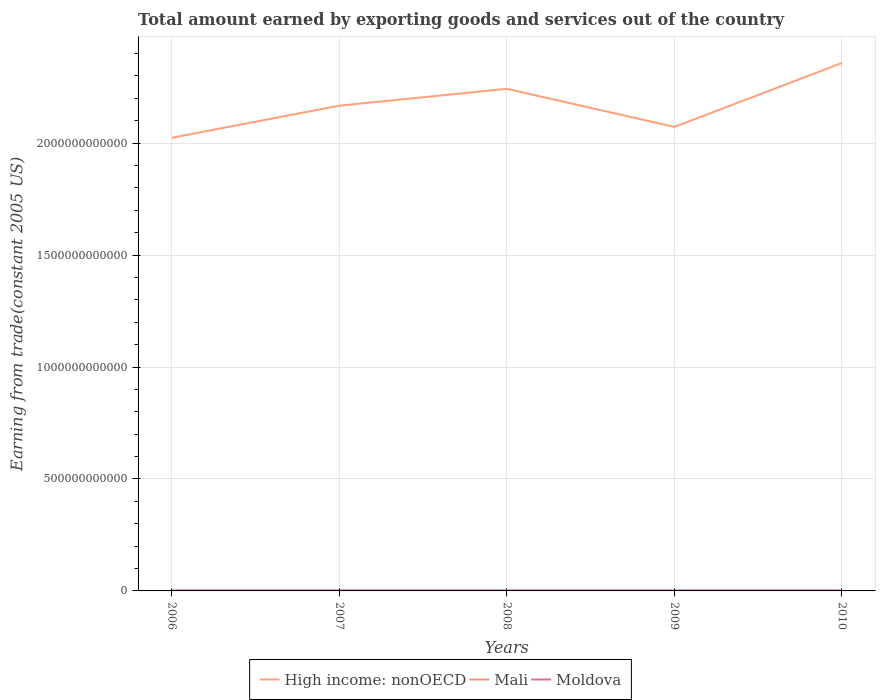How many different coloured lines are there?
Provide a succinct answer. 3. Does the line corresponding to Moldova intersect with the line corresponding to High income: nonOECD?
Ensure brevity in your answer.  No. Is the number of lines equal to the number of legend labels?
Make the answer very short. Yes. Across all years, what is the maximum total amount earned by exporting goods and services in High income: nonOECD?
Offer a very short reply. 2.02e+12. In which year was the total amount earned by exporting goods and services in High income: nonOECD maximum?
Give a very brief answer. 2006. What is the total total amount earned by exporting goods and services in High income: nonOECD in the graph?
Your response must be concise. -1.15e+11. What is the difference between the highest and the second highest total amount earned by exporting goods and services in Mali?
Your response must be concise. 1.81e+08. Is the total amount earned by exporting goods and services in Mali strictly greater than the total amount earned by exporting goods and services in Moldova over the years?
Provide a succinct answer. Yes. What is the difference between two consecutive major ticks on the Y-axis?
Offer a terse response. 5.00e+11. Does the graph contain grids?
Provide a short and direct response. Yes. Where does the legend appear in the graph?
Make the answer very short. Bottom center. How many legend labels are there?
Your response must be concise. 3. What is the title of the graph?
Give a very brief answer. Total amount earned by exporting goods and services out of the country. What is the label or title of the Y-axis?
Provide a succinct answer. Earning from trade(constant 2005 US). What is the Earning from trade(constant 2005 US) of High income: nonOECD in 2006?
Your answer should be compact. 2.02e+12. What is the Earning from trade(constant 2005 US) of Mali in 2006?
Your response must be concise. 1.39e+09. What is the Earning from trade(constant 2005 US) of Moldova in 2006?
Your response must be concise. 1.53e+09. What is the Earning from trade(constant 2005 US) of High income: nonOECD in 2007?
Your response must be concise. 2.17e+12. What is the Earning from trade(constant 2005 US) in Mali in 2007?
Your response must be concise. 1.40e+09. What is the Earning from trade(constant 2005 US) of Moldova in 2007?
Offer a terse response. 1.76e+09. What is the Earning from trade(constant 2005 US) of High income: nonOECD in 2008?
Keep it short and to the point. 2.24e+12. What is the Earning from trade(constant 2005 US) in Mali in 2008?
Keep it short and to the point. 1.22e+09. What is the Earning from trade(constant 2005 US) of Moldova in 2008?
Your answer should be compact. 1.75e+09. What is the Earning from trade(constant 2005 US) in High income: nonOECD in 2009?
Offer a terse response. 2.07e+12. What is the Earning from trade(constant 2005 US) in Mali in 2009?
Ensure brevity in your answer.  1.24e+09. What is the Earning from trade(constant 2005 US) in Moldova in 2009?
Your response must be concise. 1.53e+09. What is the Earning from trade(constant 2005 US) of High income: nonOECD in 2010?
Make the answer very short. 2.36e+12. What is the Earning from trade(constant 2005 US) in Mali in 2010?
Your response must be concise. 1.30e+09. What is the Earning from trade(constant 2005 US) of Moldova in 2010?
Your response must be concise. 1.74e+09. Across all years, what is the maximum Earning from trade(constant 2005 US) of High income: nonOECD?
Your answer should be compact. 2.36e+12. Across all years, what is the maximum Earning from trade(constant 2005 US) in Mali?
Give a very brief answer. 1.40e+09. Across all years, what is the maximum Earning from trade(constant 2005 US) of Moldova?
Give a very brief answer. 1.76e+09. Across all years, what is the minimum Earning from trade(constant 2005 US) in High income: nonOECD?
Offer a very short reply. 2.02e+12. Across all years, what is the minimum Earning from trade(constant 2005 US) of Mali?
Offer a terse response. 1.22e+09. Across all years, what is the minimum Earning from trade(constant 2005 US) of Moldova?
Offer a terse response. 1.53e+09. What is the total Earning from trade(constant 2005 US) in High income: nonOECD in the graph?
Offer a terse response. 1.09e+13. What is the total Earning from trade(constant 2005 US) of Mali in the graph?
Provide a succinct answer. 6.54e+09. What is the total Earning from trade(constant 2005 US) in Moldova in the graph?
Give a very brief answer. 8.31e+09. What is the difference between the Earning from trade(constant 2005 US) of High income: nonOECD in 2006 and that in 2007?
Make the answer very short. -1.43e+11. What is the difference between the Earning from trade(constant 2005 US) in Mali in 2006 and that in 2007?
Make the answer very short. -6.96e+06. What is the difference between the Earning from trade(constant 2005 US) in Moldova in 2006 and that in 2007?
Offer a very short reply. -2.30e+08. What is the difference between the Earning from trade(constant 2005 US) in High income: nonOECD in 2006 and that in 2008?
Your response must be concise. -2.19e+11. What is the difference between the Earning from trade(constant 2005 US) of Mali in 2006 and that in 2008?
Your response must be concise. 1.74e+08. What is the difference between the Earning from trade(constant 2005 US) of Moldova in 2006 and that in 2008?
Keep it short and to the point. -2.18e+08. What is the difference between the Earning from trade(constant 2005 US) in High income: nonOECD in 2006 and that in 2009?
Offer a very short reply. -4.86e+1. What is the difference between the Earning from trade(constant 2005 US) of Mali in 2006 and that in 2009?
Your answer should be compact. 1.56e+08. What is the difference between the Earning from trade(constant 2005 US) in Moldova in 2006 and that in 2009?
Make the answer very short. -7.12e+06. What is the difference between the Earning from trade(constant 2005 US) in High income: nonOECD in 2006 and that in 2010?
Ensure brevity in your answer.  -3.34e+11. What is the difference between the Earning from trade(constant 2005 US) of Mali in 2006 and that in 2010?
Your response must be concise. 8.84e+07. What is the difference between the Earning from trade(constant 2005 US) of Moldova in 2006 and that in 2010?
Provide a succinct answer. -2.18e+08. What is the difference between the Earning from trade(constant 2005 US) of High income: nonOECD in 2007 and that in 2008?
Make the answer very short. -7.52e+1. What is the difference between the Earning from trade(constant 2005 US) of Mali in 2007 and that in 2008?
Offer a very short reply. 1.81e+08. What is the difference between the Earning from trade(constant 2005 US) in Moldova in 2007 and that in 2008?
Your answer should be very brief. 1.15e+07. What is the difference between the Earning from trade(constant 2005 US) in High income: nonOECD in 2007 and that in 2009?
Ensure brevity in your answer.  9.49e+1. What is the difference between the Earning from trade(constant 2005 US) of Mali in 2007 and that in 2009?
Provide a short and direct response. 1.63e+08. What is the difference between the Earning from trade(constant 2005 US) in Moldova in 2007 and that in 2009?
Provide a succinct answer. 2.23e+08. What is the difference between the Earning from trade(constant 2005 US) of High income: nonOECD in 2007 and that in 2010?
Your response must be concise. -1.91e+11. What is the difference between the Earning from trade(constant 2005 US) in Mali in 2007 and that in 2010?
Ensure brevity in your answer.  9.54e+07. What is the difference between the Earning from trade(constant 2005 US) in Moldova in 2007 and that in 2010?
Offer a terse response. 1.21e+07. What is the difference between the Earning from trade(constant 2005 US) of High income: nonOECD in 2008 and that in 2009?
Provide a succinct answer. 1.70e+11. What is the difference between the Earning from trade(constant 2005 US) in Mali in 2008 and that in 2009?
Your answer should be very brief. -1.82e+07. What is the difference between the Earning from trade(constant 2005 US) in Moldova in 2008 and that in 2009?
Your answer should be very brief. 2.11e+08. What is the difference between the Earning from trade(constant 2005 US) in High income: nonOECD in 2008 and that in 2010?
Ensure brevity in your answer.  -1.15e+11. What is the difference between the Earning from trade(constant 2005 US) of Mali in 2008 and that in 2010?
Offer a terse response. -8.58e+07. What is the difference between the Earning from trade(constant 2005 US) of Moldova in 2008 and that in 2010?
Your answer should be compact. 5.94e+05. What is the difference between the Earning from trade(constant 2005 US) of High income: nonOECD in 2009 and that in 2010?
Ensure brevity in your answer.  -2.86e+11. What is the difference between the Earning from trade(constant 2005 US) in Mali in 2009 and that in 2010?
Provide a short and direct response. -6.75e+07. What is the difference between the Earning from trade(constant 2005 US) of Moldova in 2009 and that in 2010?
Offer a terse response. -2.11e+08. What is the difference between the Earning from trade(constant 2005 US) of High income: nonOECD in 2006 and the Earning from trade(constant 2005 US) of Mali in 2007?
Your response must be concise. 2.02e+12. What is the difference between the Earning from trade(constant 2005 US) of High income: nonOECD in 2006 and the Earning from trade(constant 2005 US) of Moldova in 2007?
Make the answer very short. 2.02e+12. What is the difference between the Earning from trade(constant 2005 US) in Mali in 2006 and the Earning from trade(constant 2005 US) in Moldova in 2007?
Keep it short and to the point. -3.65e+08. What is the difference between the Earning from trade(constant 2005 US) of High income: nonOECD in 2006 and the Earning from trade(constant 2005 US) of Mali in 2008?
Make the answer very short. 2.02e+12. What is the difference between the Earning from trade(constant 2005 US) of High income: nonOECD in 2006 and the Earning from trade(constant 2005 US) of Moldova in 2008?
Offer a terse response. 2.02e+12. What is the difference between the Earning from trade(constant 2005 US) of Mali in 2006 and the Earning from trade(constant 2005 US) of Moldova in 2008?
Give a very brief answer. -3.54e+08. What is the difference between the Earning from trade(constant 2005 US) of High income: nonOECD in 2006 and the Earning from trade(constant 2005 US) of Mali in 2009?
Your answer should be compact. 2.02e+12. What is the difference between the Earning from trade(constant 2005 US) of High income: nonOECD in 2006 and the Earning from trade(constant 2005 US) of Moldova in 2009?
Offer a very short reply. 2.02e+12. What is the difference between the Earning from trade(constant 2005 US) of Mali in 2006 and the Earning from trade(constant 2005 US) of Moldova in 2009?
Your answer should be compact. -1.43e+08. What is the difference between the Earning from trade(constant 2005 US) of High income: nonOECD in 2006 and the Earning from trade(constant 2005 US) of Mali in 2010?
Keep it short and to the point. 2.02e+12. What is the difference between the Earning from trade(constant 2005 US) of High income: nonOECD in 2006 and the Earning from trade(constant 2005 US) of Moldova in 2010?
Keep it short and to the point. 2.02e+12. What is the difference between the Earning from trade(constant 2005 US) of Mali in 2006 and the Earning from trade(constant 2005 US) of Moldova in 2010?
Provide a short and direct response. -3.53e+08. What is the difference between the Earning from trade(constant 2005 US) of High income: nonOECD in 2007 and the Earning from trade(constant 2005 US) of Mali in 2008?
Ensure brevity in your answer.  2.17e+12. What is the difference between the Earning from trade(constant 2005 US) in High income: nonOECD in 2007 and the Earning from trade(constant 2005 US) in Moldova in 2008?
Provide a short and direct response. 2.17e+12. What is the difference between the Earning from trade(constant 2005 US) of Mali in 2007 and the Earning from trade(constant 2005 US) of Moldova in 2008?
Your response must be concise. -3.47e+08. What is the difference between the Earning from trade(constant 2005 US) in High income: nonOECD in 2007 and the Earning from trade(constant 2005 US) in Mali in 2009?
Make the answer very short. 2.17e+12. What is the difference between the Earning from trade(constant 2005 US) in High income: nonOECD in 2007 and the Earning from trade(constant 2005 US) in Moldova in 2009?
Offer a terse response. 2.17e+12. What is the difference between the Earning from trade(constant 2005 US) of Mali in 2007 and the Earning from trade(constant 2005 US) of Moldova in 2009?
Offer a terse response. -1.36e+08. What is the difference between the Earning from trade(constant 2005 US) of High income: nonOECD in 2007 and the Earning from trade(constant 2005 US) of Mali in 2010?
Your answer should be very brief. 2.17e+12. What is the difference between the Earning from trade(constant 2005 US) in High income: nonOECD in 2007 and the Earning from trade(constant 2005 US) in Moldova in 2010?
Your answer should be very brief. 2.17e+12. What is the difference between the Earning from trade(constant 2005 US) in Mali in 2007 and the Earning from trade(constant 2005 US) in Moldova in 2010?
Provide a succinct answer. -3.46e+08. What is the difference between the Earning from trade(constant 2005 US) of High income: nonOECD in 2008 and the Earning from trade(constant 2005 US) of Mali in 2009?
Provide a succinct answer. 2.24e+12. What is the difference between the Earning from trade(constant 2005 US) of High income: nonOECD in 2008 and the Earning from trade(constant 2005 US) of Moldova in 2009?
Your answer should be compact. 2.24e+12. What is the difference between the Earning from trade(constant 2005 US) of Mali in 2008 and the Earning from trade(constant 2005 US) of Moldova in 2009?
Provide a short and direct response. -3.17e+08. What is the difference between the Earning from trade(constant 2005 US) in High income: nonOECD in 2008 and the Earning from trade(constant 2005 US) in Mali in 2010?
Your answer should be very brief. 2.24e+12. What is the difference between the Earning from trade(constant 2005 US) in High income: nonOECD in 2008 and the Earning from trade(constant 2005 US) in Moldova in 2010?
Offer a terse response. 2.24e+12. What is the difference between the Earning from trade(constant 2005 US) in Mali in 2008 and the Earning from trade(constant 2005 US) in Moldova in 2010?
Provide a short and direct response. -5.28e+08. What is the difference between the Earning from trade(constant 2005 US) of High income: nonOECD in 2009 and the Earning from trade(constant 2005 US) of Mali in 2010?
Your answer should be very brief. 2.07e+12. What is the difference between the Earning from trade(constant 2005 US) in High income: nonOECD in 2009 and the Earning from trade(constant 2005 US) in Moldova in 2010?
Keep it short and to the point. 2.07e+12. What is the difference between the Earning from trade(constant 2005 US) in Mali in 2009 and the Earning from trade(constant 2005 US) in Moldova in 2010?
Give a very brief answer. -5.09e+08. What is the average Earning from trade(constant 2005 US) in High income: nonOECD per year?
Make the answer very short. 2.17e+12. What is the average Earning from trade(constant 2005 US) in Mali per year?
Provide a succinct answer. 1.31e+09. What is the average Earning from trade(constant 2005 US) in Moldova per year?
Offer a terse response. 1.66e+09. In the year 2006, what is the difference between the Earning from trade(constant 2005 US) in High income: nonOECD and Earning from trade(constant 2005 US) in Mali?
Provide a short and direct response. 2.02e+12. In the year 2006, what is the difference between the Earning from trade(constant 2005 US) of High income: nonOECD and Earning from trade(constant 2005 US) of Moldova?
Keep it short and to the point. 2.02e+12. In the year 2006, what is the difference between the Earning from trade(constant 2005 US) of Mali and Earning from trade(constant 2005 US) of Moldova?
Offer a very short reply. -1.36e+08. In the year 2007, what is the difference between the Earning from trade(constant 2005 US) in High income: nonOECD and Earning from trade(constant 2005 US) in Mali?
Provide a succinct answer. 2.17e+12. In the year 2007, what is the difference between the Earning from trade(constant 2005 US) in High income: nonOECD and Earning from trade(constant 2005 US) in Moldova?
Your response must be concise. 2.17e+12. In the year 2007, what is the difference between the Earning from trade(constant 2005 US) of Mali and Earning from trade(constant 2005 US) of Moldova?
Give a very brief answer. -3.58e+08. In the year 2008, what is the difference between the Earning from trade(constant 2005 US) in High income: nonOECD and Earning from trade(constant 2005 US) in Mali?
Your answer should be very brief. 2.24e+12. In the year 2008, what is the difference between the Earning from trade(constant 2005 US) of High income: nonOECD and Earning from trade(constant 2005 US) of Moldova?
Provide a succinct answer. 2.24e+12. In the year 2008, what is the difference between the Earning from trade(constant 2005 US) in Mali and Earning from trade(constant 2005 US) in Moldova?
Ensure brevity in your answer.  -5.28e+08. In the year 2009, what is the difference between the Earning from trade(constant 2005 US) of High income: nonOECD and Earning from trade(constant 2005 US) of Mali?
Provide a succinct answer. 2.07e+12. In the year 2009, what is the difference between the Earning from trade(constant 2005 US) in High income: nonOECD and Earning from trade(constant 2005 US) in Moldova?
Your answer should be compact. 2.07e+12. In the year 2009, what is the difference between the Earning from trade(constant 2005 US) in Mali and Earning from trade(constant 2005 US) in Moldova?
Offer a terse response. -2.99e+08. In the year 2010, what is the difference between the Earning from trade(constant 2005 US) of High income: nonOECD and Earning from trade(constant 2005 US) of Mali?
Offer a very short reply. 2.36e+12. In the year 2010, what is the difference between the Earning from trade(constant 2005 US) in High income: nonOECD and Earning from trade(constant 2005 US) in Moldova?
Provide a short and direct response. 2.36e+12. In the year 2010, what is the difference between the Earning from trade(constant 2005 US) of Mali and Earning from trade(constant 2005 US) of Moldova?
Make the answer very short. -4.42e+08. What is the ratio of the Earning from trade(constant 2005 US) of High income: nonOECD in 2006 to that in 2007?
Give a very brief answer. 0.93. What is the ratio of the Earning from trade(constant 2005 US) of Mali in 2006 to that in 2007?
Your answer should be very brief. 0.99. What is the ratio of the Earning from trade(constant 2005 US) in Moldova in 2006 to that in 2007?
Offer a terse response. 0.87. What is the ratio of the Earning from trade(constant 2005 US) of High income: nonOECD in 2006 to that in 2008?
Keep it short and to the point. 0.9. What is the ratio of the Earning from trade(constant 2005 US) in Mali in 2006 to that in 2008?
Offer a terse response. 1.14. What is the ratio of the Earning from trade(constant 2005 US) in Moldova in 2006 to that in 2008?
Offer a very short reply. 0.87. What is the ratio of the Earning from trade(constant 2005 US) in High income: nonOECD in 2006 to that in 2009?
Make the answer very short. 0.98. What is the ratio of the Earning from trade(constant 2005 US) of Mali in 2006 to that in 2009?
Ensure brevity in your answer.  1.13. What is the ratio of the Earning from trade(constant 2005 US) of High income: nonOECD in 2006 to that in 2010?
Ensure brevity in your answer.  0.86. What is the ratio of the Earning from trade(constant 2005 US) of Mali in 2006 to that in 2010?
Your response must be concise. 1.07. What is the ratio of the Earning from trade(constant 2005 US) in Moldova in 2006 to that in 2010?
Your answer should be very brief. 0.88. What is the ratio of the Earning from trade(constant 2005 US) in High income: nonOECD in 2007 to that in 2008?
Your answer should be compact. 0.97. What is the ratio of the Earning from trade(constant 2005 US) of Mali in 2007 to that in 2008?
Your answer should be very brief. 1.15. What is the ratio of the Earning from trade(constant 2005 US) in Moldova in 2007 to that in 2008?
Provide a short and direct response. 1.01. What is the ratio of the Earning from trade(constant 2005 US) in High income: nonOECD in 2007 to that in 2009?
Keep it short and to the point. 1.05. What is the ratio of the Earning from trade(constant 2005 US) in Mali in 2007 to that in 2009?
Give a very brief answer. 1.13. What is the ratio of the Earning from trade(constant 2005 US) of Moldova in 2007 to that in 2009?
Keep it short and to the point. 1.15. What is the ratio of the Earning from trade(constant 2005 US) in High income: nonOECD in 2007 to that in 2010?
Keep it short and to the point. 0.92. What is the ratio of the Earning from trade(constant 2005 US) in Mali in 2007 to that in 2010?
Your answer should be compact. 1.07. What is the ratio of the Earning from trade(constant 2005 US) of High income: nonOECD in 2008 to that in 2009?
Give a very brief answer. 1.08. What is the ratio of the Earning from trade(constant 2005 US) of Mali in 2008 to that in 2009?
Your answer should be very brief. 0.99. What is the ratio of the Earning from trade(constant 2005 US) in Moldova in 2008 to that in 2009?
Give a very brief answer. 1.14. What is the ratio of the Earning from trade(constant 2005 US) of High income: nonOECD in 2008 to that in 2010?
Ensure brevity in your answer.  0.95. What is the ratio of the Earning from trade(constant 2005 US) of Mali in 2008 to that in 2010?
Provide a short and direct response. 0.93. What is the ratio of the Earning from trade(constant 2005 US) of Moldova in 2008 to that in 2010?
Your answer should be compact. 1. What is the ratio of the Earning from trade(constant 2005 US) in High income: nonOECD in 2009 to that in 2010?
Keep it short and to the point. 0.88. What is the ratio of the Earning from trade(constant 2005 US) in Mali in 2009 to that in 2010?
Keep it short and to the point. 0.95. What is the ratio of the Earning from trade(constant 2005 US) of Moldova in 2009 to that in 2010?
Offer a terse response. 0.88. What is the difference between the highest and the second highest Earning from trade(constant 2005 US) in High income: nonOECD?
Make the answer very short. 1.15e+11. What is the difference between the highest and the second highest Earning from trade(constant 2005 US) of Mali?
Keep it short and to the point. 6.96e+06. What is the difference between the highest and the second highest Earning from trade(constant 2005 US) of Moldova?
Your answer should be compact. 1.15e+07. What is the difference between the highest and the lowest Earning from trade(constant 2005 US) of High income: nonOECD?
Your answer should be compact. 3.34e+11. What is the difference between the highest and the lowest Earning from trade(constant 2005 US) of Mali?
Give a very brief answer. 1.81e+08. What is the difference between the highest and the lowest Earning from trade(constant 2005 US) of Moldova?
Your answer should be very brief. 2.30e+08. 